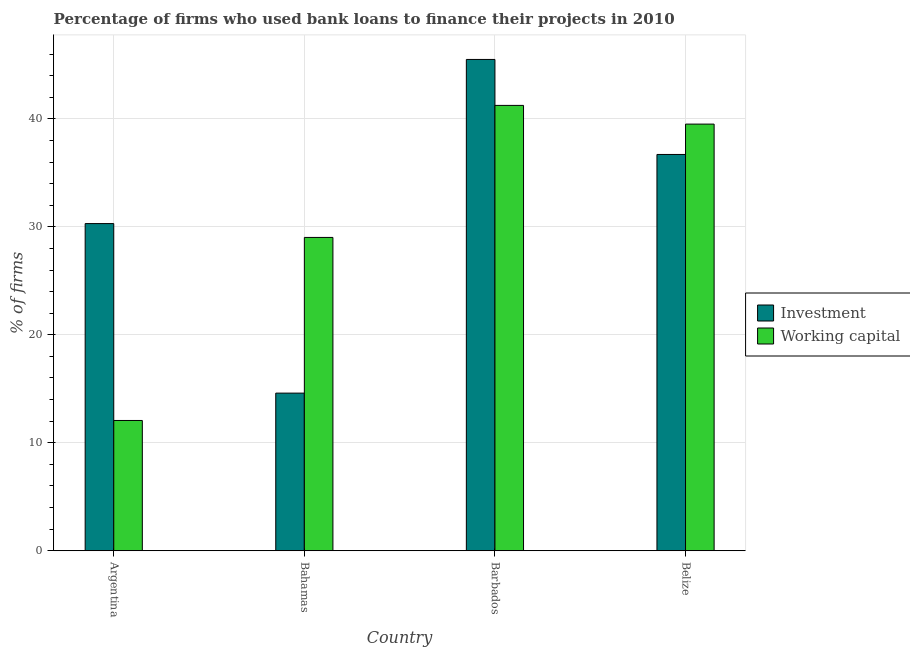Are the number of bars per tick equal to the number of legend labels?
Make the answer very short. Yes. How many bars are there on the 2nd tick from the right?
Your answer should be compact. 2. What is the label of the 3rd group of bars from the left?
Offer a very short reply. Barbados. What is the percentage of firms using banks to finance investment in Barbados?
Your answer should be compact. 45.5. Across all countries, what is the maximum percentage of firms using banks to finance investment?
Provide a succinct answer. 45.5. Across all countries, what is the minimum percentage of firms using banks to finance working capital?
Provide a short and direct response. 12.07. In which country was the percentage of firms using banks to finance investment maximum?
Your answer should be compact. Barbados. In which country was the percentage of firms using banks to finance investment minimum?
Your answer should be very brief. Bahamas. What is the total percentage of firms using banks to finance investment in the graph?
Offer a terse response. 127.1. What is the difference between the percentage of firms using banks to finance investment in Argentina and that in Barbados?
Your answer should be compact. -15.2. What is the difference between the percentage of firms using banks to finance investment in Argentina and the percentage of firms using banks to finance working capital in Barbados?
Ensure brevity in your answer.  -10.94. What is the average percentage of firms using banks to finance working capital per country?
Provide a succinct answer. 30.46. What is the difference between the percentage of firms using banks to finance working capital and percentage of firms using banks to finance investment in Belize?
Offer a terse response. 2.81. In how many countries, is the percentage of firms using banks to finance working capital greater than 18 %?
Give a very brief answer. 3. What is the ratio of the percentage of firms using banks to finance investment in Argentina to that in Barbados?
Ensure brevity in your answer.  0.67. What is the difference between the highest and the second highest percentage of firms using banks to finance investment?
Your answer should be compact. 8.8. What is the difference between the highest and the lowest percentage of firms using banks to finance investment?
Provide a succinct answer. 30.9. In how many countries, is the percentage of firms using banks to finance investment greater than the average percentage of firms using banks to finance investment taken over all countries?
Give a very brief answer. 2. What does the 1st bar from the left in Barbados represents?
Provide a succinct answer. Investment. What does the 2nd bar from the right in Belize represents?
Provide a succinct answer. Investment. Are all the bars in the graph horizontal?
Your answer should be compact. No. What is the difference between two consecutive major ticks on the Y-axis?
Ensure brevity in your answer.  10. Are the values on the major ticks of Y-axis written in scientific E-notation?
Provide a short and direct response. No. Does the graph contain any zero values?
Ensure brevity in your answer.  No. Does the graph contain grids?
Your answer should be compact. Yes. Where does the legend appear in the graph?
Give a very brief answer. Center right. How are the legend labels stacked?
Your response must be concise. Vertical. What is the title of the graph?
Provide a short and direct response. Percentage of firms who used bank loans to finance their projects in 2010. What is the label or title of the Y-axis?
Your answer should be very brief. % of firms. What is the % of firms in Investment in Argentina?
Your response must be concise. 30.3. What is the % of firms in Working capital in Argentina?
Provide a succinct answer. 12.07. What is the % of firms in Working capital in Bahamas?
Give a very brief answer. 29.02. What is the % of firms of Investment in Barbados?
Offer a very short reply. 45.5. What is the % of firms of Working capital in Barbados?
Make the answer very short. 41.24. What is the % of firms of Investment in Belize?
Offer a very short reply. 36.7. What is the % of firms of Working capital in Belize?
Make the answer very short. 39.51. Across all countries, what is the maximum % of firms of Investment?
Provide a succinct answer. 45.5. Across all countries, what is the maximum % of firms of Working capital?
Offer a very short reply. 41.24. Across all countries, what is the minimum % of firms of Investment?
Make the answer very short. 14.6. Across all countries, what is the minimum % of firms of Working capital?
Keep it short and to the point. 12.07. What is the total % of firms in Investment in the graph?
Offer a very short reply. 127.1. What is the total % of firms in Working capital in the graph?
Your answer should be compact. 121.84. What is the difference between the % of firms of Working capital in Argentina and that in Bahamas?
Offer a terse response. -16.95. What is the difference between the % of firms of Investment in Argentina and that in Barbados?
Offer a terse response. -15.2. What is the difference between the % of firms in Working capital in Argentina and that in Barbados?
Offer a terse response. -29.18. What is the difference between the % of firms of Working capital in Argentina and that in Belize?
Your answer should be compact. -27.45. What is the difference between the % of firms of Investment in Bahamas and that in Barbados?
Offer a very short reply. -30.9. What is the difference between the % of firms of Working capital in Bahamas and that in Barbados?
Provide a succinct answer. -12.23. What is the difference between the % of firms in Investment in Bahamas and that in Belize?
Make the answer very short. -22.1. What is the difference between the % of firms of Working capital in Bahamas and that in Belize?
Ensure brevity in your answer.  -10.5. What is the difference between the % of firms of Investment in Barbados and that in Belize?
Keep it short and to the point. 8.8. What is the difference between the % of firms of Working capital in Barbados and that in Belize?
Your answer should be compact. 1.73. What is the difference between the % of firms in Investment in Argentina and the % of firms in Working capital in Bahamas?
Provide a succinct answer. 1.28. What is the difference between the % of firms in Investment in Argentina and the % of firms in Working capital in Barbados?
Your response must be concise. -10.94. What is the difference between the % of firms of Investment in Argentina and the % of firms of Working capital in Belize?
Offer a very short reply. -9.21. What is the difference between the % of firms in Investment in Bahamas and the % of firms in Working capital in Barbados?
Provide a short and direct response. -26.64. What is the difference between the % of firms of Investment in Bahamas and the % of firms of Working capital in Belize?
Make the answer very short. -24.91. What is the difference between the % of firms in Investment in Barbados and the % of firms in Working capital in Belize?
Provide a succinct answer. 5.99. What is the average % of firms in Investment per country?
Offer a terse response. 31.77. What is the average % of firms in Working capital per country?
Offer a very short reply. 30.46. What is the difference between the % of firms of Investment and % of firms of Working capital in Argentina?
Ensure brevity in your answer.  18.23. What is the difference between the % of firms in Investment and % of firms in Working capital in Bahamas?
Make the answer very short. -14.42. What is the difference between the % of firms in Investment and % of firms in Working capital in Barbados?
Ensure brevity in your answer.  4.26. What is the difference between the % of firms of Investment and % of firms of Working capital in Belize?
Offer a terse response. -2.81. What is the ratio of the % of firms in Investment in Argentina to that in Bahamas?
Your response must be concise. 2.08. What is the ratio of the % of firms in Working capital in Argentina to that in Bahamas?
Offer a very short reply. 0.42. What is the ratio of the % of firms of Investment in Argentina to that in Barbados?
Ensure brevity in your answer.  0.67. What is the ratio of the % of firms of Working capital in Argentina to that in Barbados?
Make the answer very short. 0.29. What is the ratio of the % of firms of Investment in Argentina to that in Belize?
Make the answer very short. 0.83. What is the ratio of the % of firms in Working capital in Argentina to that in Belize?
Make the answer very short. 0.31. What is the ratio of the % of firms of Investment in Bahamas to that in Barbados?
Provide a short and direct response. 0.32. What is the ratio of the % of firms of Working capital in Bahamas to that in Barbados?
Make the answer very short. 0.7. What is the ratio of the % of firms of Investment in Bahamas to that in Belize?
Give a very brief answer. 0.4. What is the ratio of the % of firms in Working capital in Bahamas to that in Belize?
Keep it short and to the point. 0.73. What is the ratio of the % of firms in Investment in Barbados to that in Belize?
Your response must be concise. 1.24. What is the ratio of the % of firms in Working capital in Barbados to that in Belize?
Your answer should be compact. 1.04. What is the difference between the highest and the second highest % of firms of Working capital?
Offer a very short reply. 1.73. What is the difference between the highest and the lowest % of firms of Investment?
Make the answer very short. 30.9. What is the difference between the highest and the lowest % of firms in Working capital?
Give a very brief answer. 29.18. 